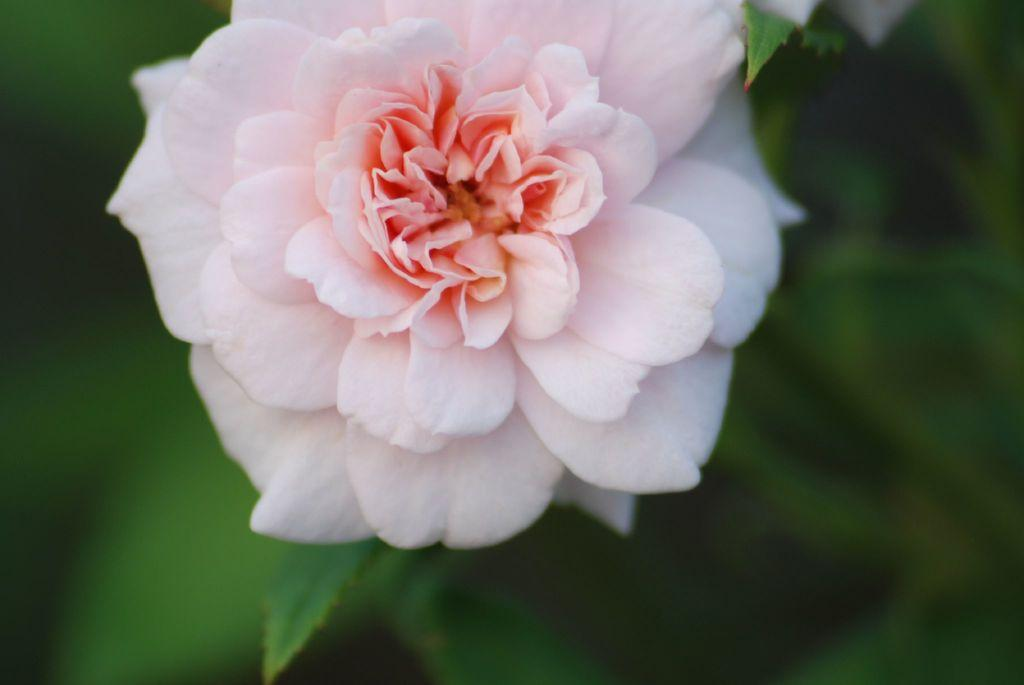What type of living organism can be seen in the image? There is a flower on a plant in the image. What type of shoes is the flower wearing in the image? There are no shoes present in the image, as flowers do not wear shoes. 